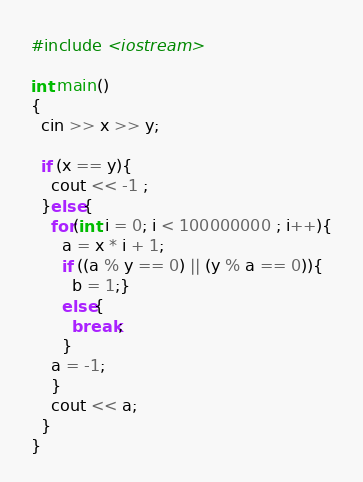<code> <loc_0><loc_0><loc_500><loc_500><_C++_>#include <iostream>

int main()
{
  cin >> x >> y;

  if (x == y){
    cout << -1 ;
  }else{
    for(int i = 0; i < 100000000 ; i++){
      a = x * i + 1;
      if ((a % y == 0) || (y % a == 0)){
        b = 1;}
      else{
        break;
      }
    a = -1;
    }
    cout << a;
  }
}</code> 